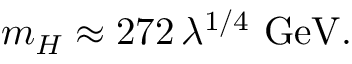Convert formula to latex. <formula><loc_0><loc_0><loc_500><loc_500>m _ { H } \approx 2 7 2 \, \lambda ^ { 1 / 4 } \ G e V .</formula> 